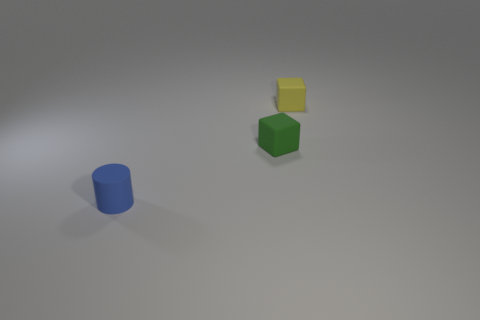What is the color of the matte cylinder?
Make the answer very short. Blue. There is a object that is left of the green rubber object; does it have the same shape as the yellow object?
Provide a short and direct response. No. What is the material of the green object?
Offer a terse response. Rubber. There is a yellow rubber object that is the same size as the green matte cube; what shape is it?
Offer a very short reply. Cube. Is there another small cylinder that has the same color as the tiny rubber cylinder?
Your answer should be compact. No. Do the small cylinder and the small cube that is on the left side of the yellow matte cube have the same color?
Provide a short and direct response. No. What is the color of the small block left of the tiny cube that is behind the green cube?
Provide a succinct answer. Green. Is there a cylinder that is behind the rubber block in front of the small cube that is behind the small green thing?
Make the answer very short. No. There is a cylinder that is made of the same material as the yellow cube; what is its color?
Your answer should be very brief. Blue. How many other cubes are the same material as the yellow block?
Keep it short and to the point. 1. 